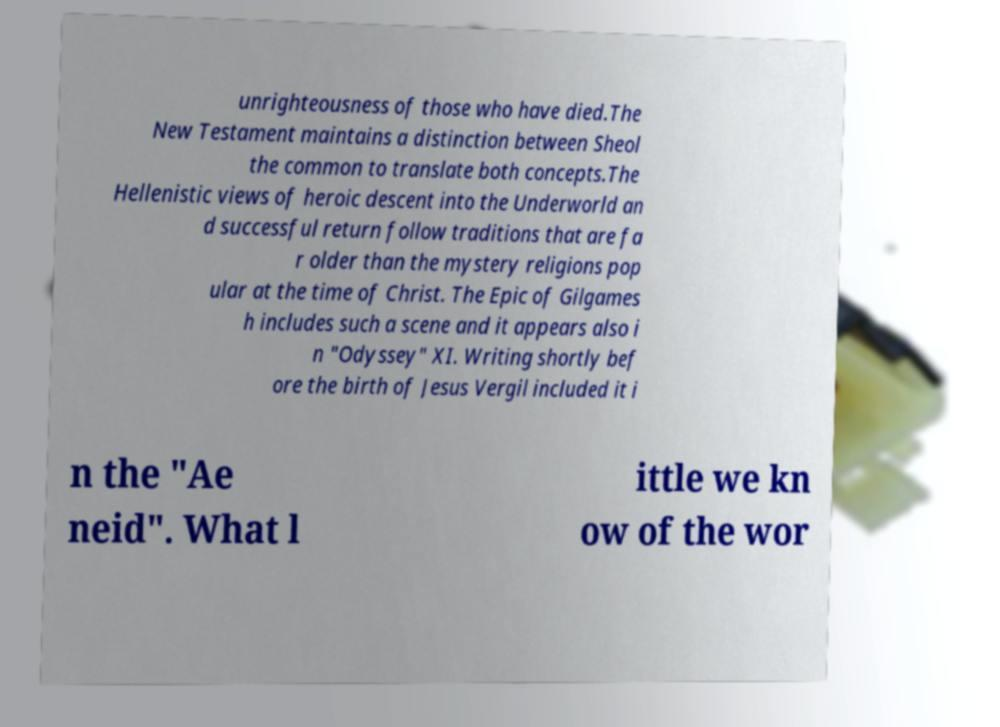Please identify and transcribe the text found in this image. unrighteousness of those who have died.The New Testament maintains a distinction between Sheol the common to translate both concepts.The Hellenistic views of heroic descent into the Underworld an d successful return follow traditions that are fa r older than the mystery religions pop ular at the time of Christ. The Epic of Gilgames h includes such a scene and it appears also i n "Odyssey" XI. Writing shortly bef ore the birth of Jesus Vergil included it i n the "Ae neid". What l ittle we kn ow of the wor 